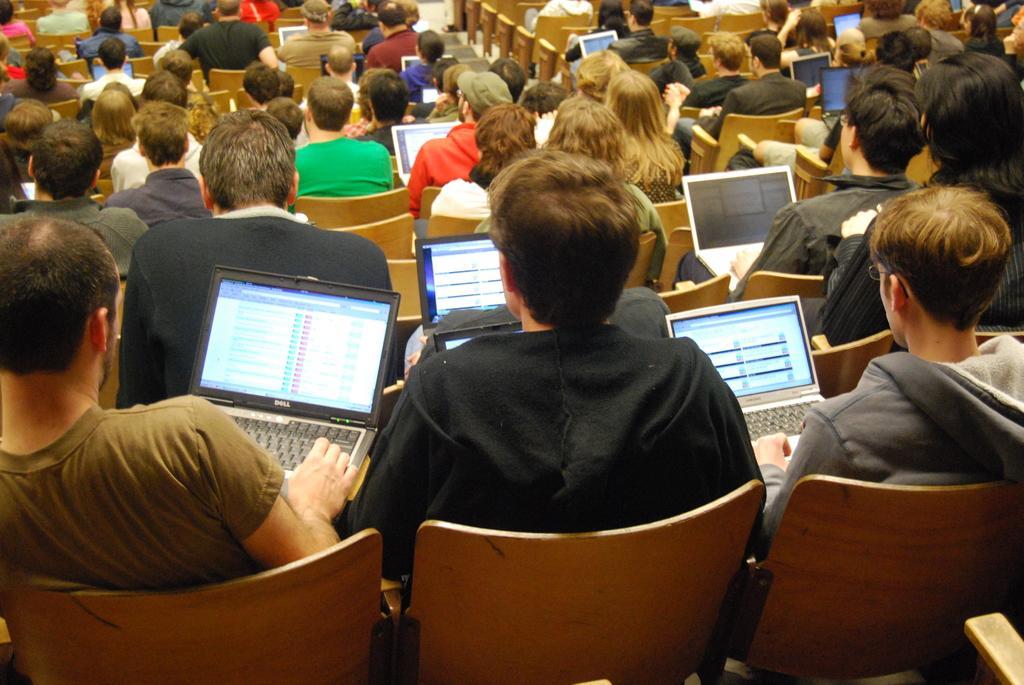Please provide a concise description of this image. There are group of people sitting on chairs and we can see laptops. 